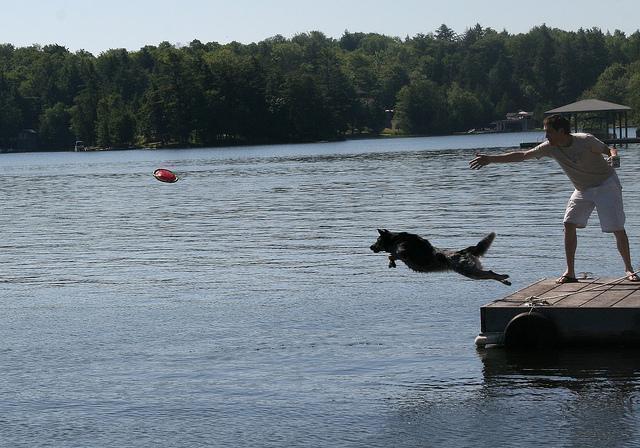What is the object called that the dog is jumping into the water after?
Choose the correct response and explain in the format: 'Answer: answer
Rationale: rationale.'
Options: Football, ball, bone, frisbee. Answer: frisbee.
Rationale: A frisbee attracts the dog easily. 